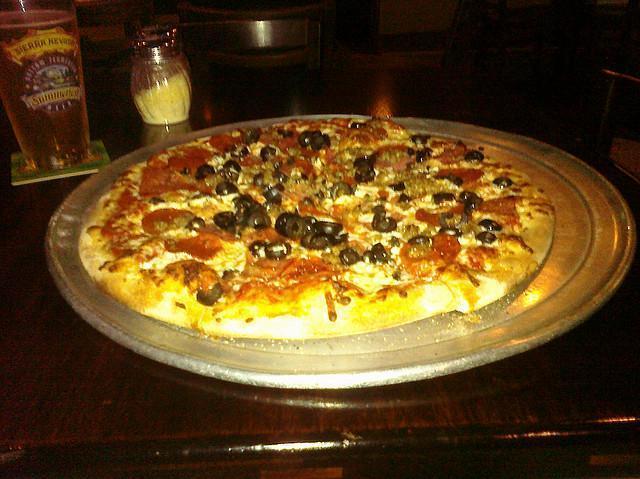How many slices are there?
Give a very brief answer. 8. How many bottles are in the photo?
Give a very brief answer. 2. 